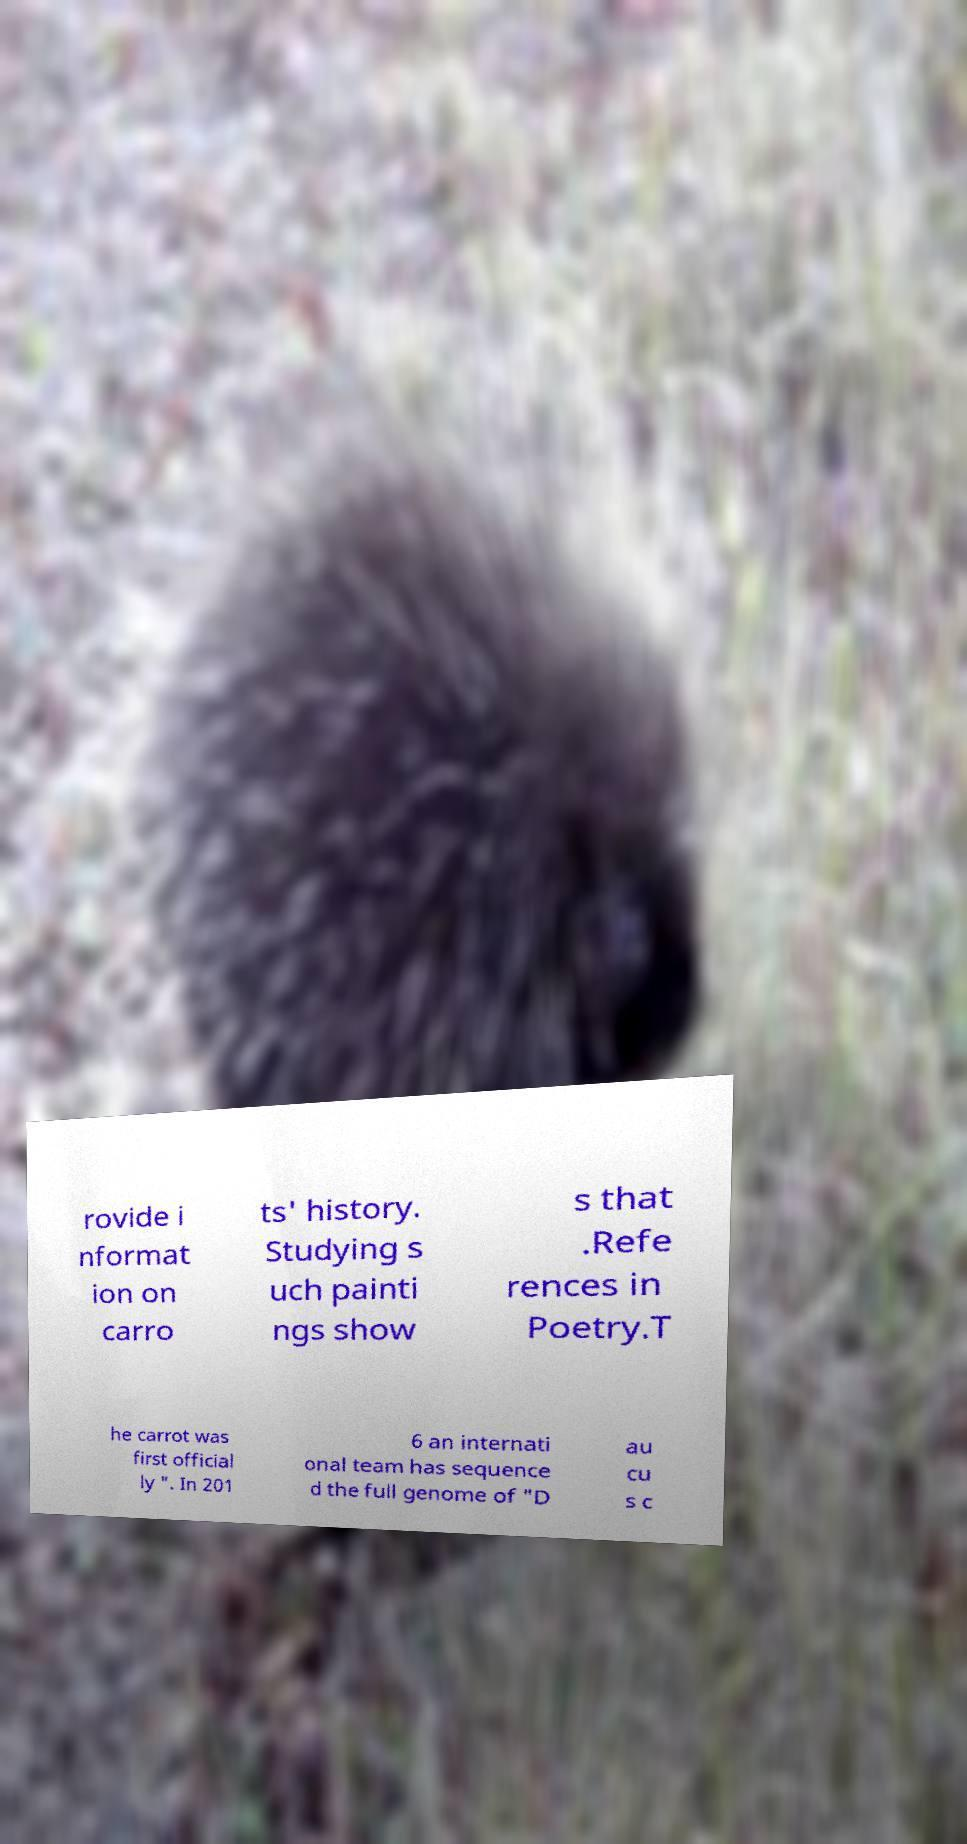For documentation purposes, I need the text within this image transcribed. Could you provide that? rovide i nformat ion on carro ts' history. Studying s uch painti ngs show s that .Refe rences in Poetry.T he carrot was first official ly ". In 201 6 an internati onal team has sequence d the full genome of "D au cu s c 